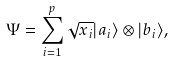<formula> <loc_0><loc_0><loc_500><loc_500>\Psi = \sum _ { i = 1 } ^ { p } \sqrt { x _ { i } } | a _ { i } \rangle \otimes | b _ { i } \rangle ,</formula> 